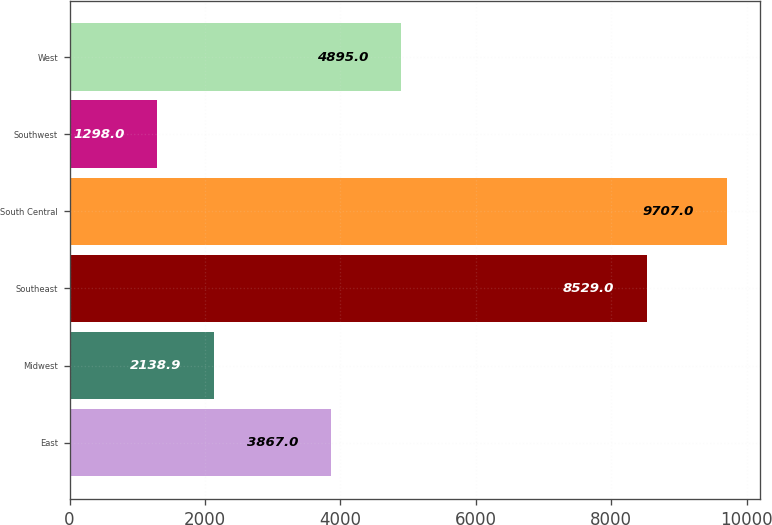Convert chart to OTSL. <chart><loc_0><loc_0><loc_500><loc_500><bar_chart><fcel>East<fcel>Midwest<fcel>Southeast<fcel>South Central<fcel>Southwest<fcel>West<nl><fcel>3867<fcel>2138.9<fcel>8529<fcel>9707<fcel>1298<fcel>4895<nl></chart> 